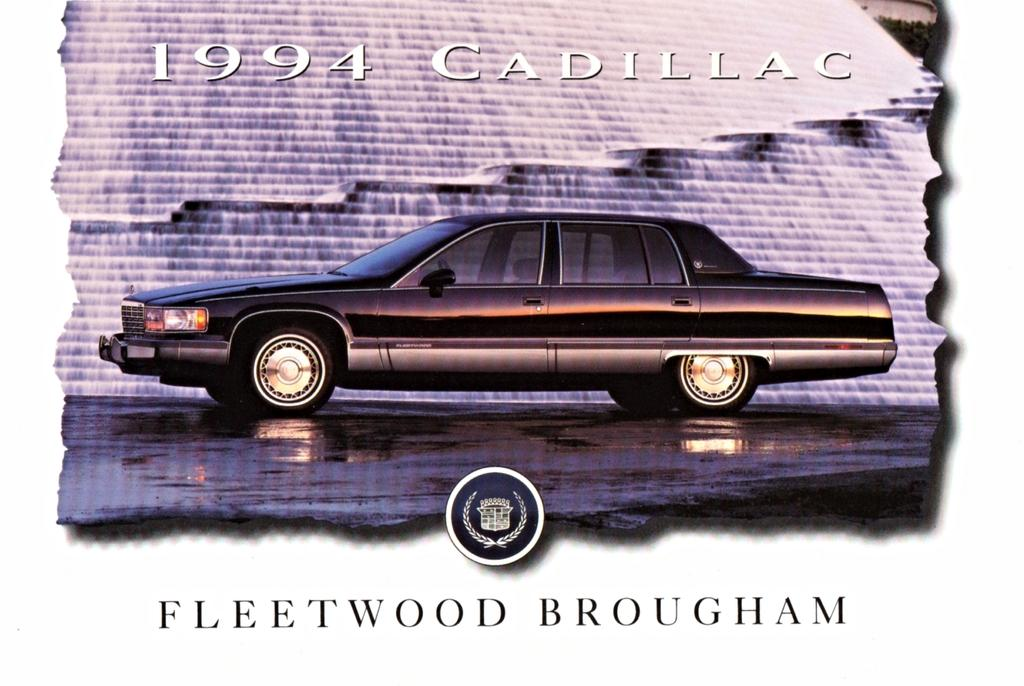What color is the car in the image? The car in the image is black. What can be seen in the background of the image? There is water visible in the image. What type of bed is visible in the image? There is no bed present in the image; it features a black car and water. 